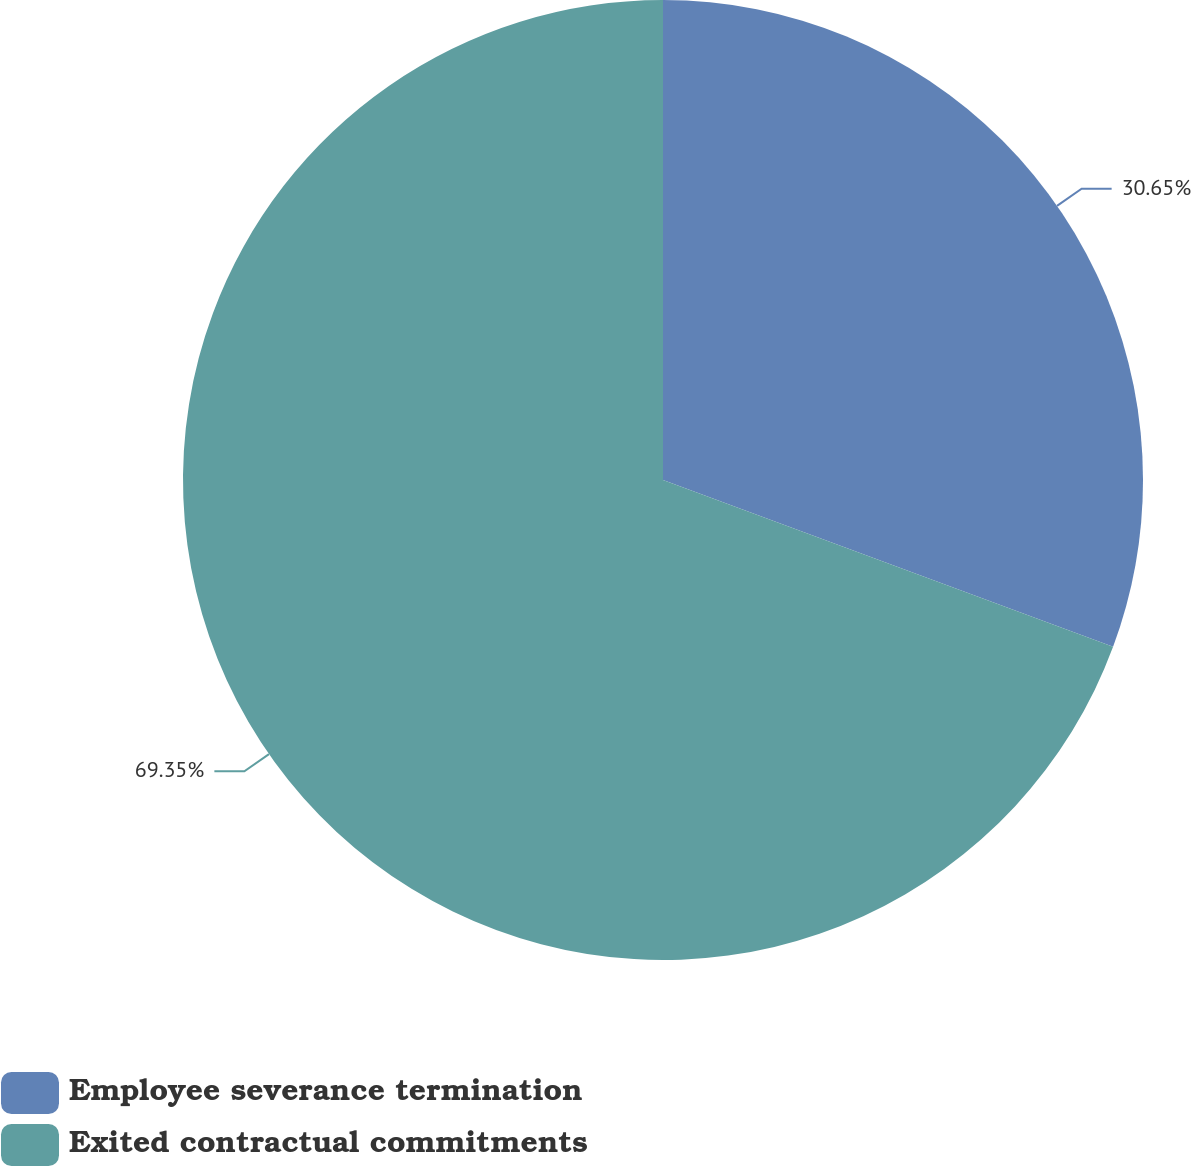<chart> <loc_0><loc_0><loc_500><loc_500><pie_chart><fcel>Employee severance termination<fcel>Exited contractual commitments<nl><fcel>30.65%<fcel>69.35%<nl></chart> 